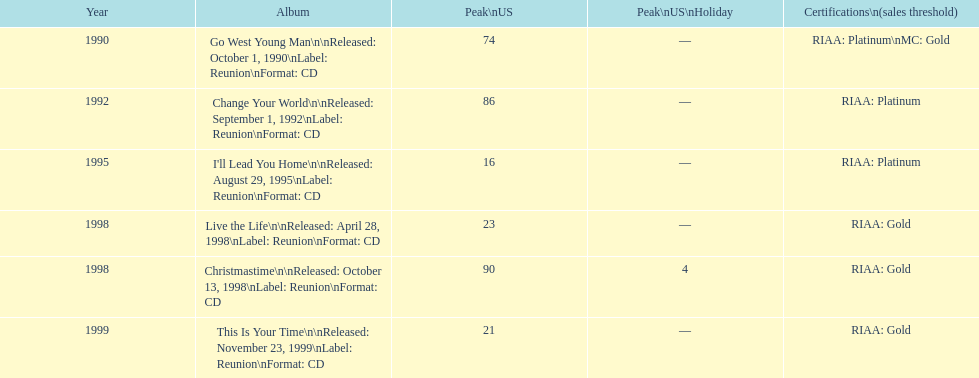How many albums by michael w. smith reached the top 25 in the charts? 3. 